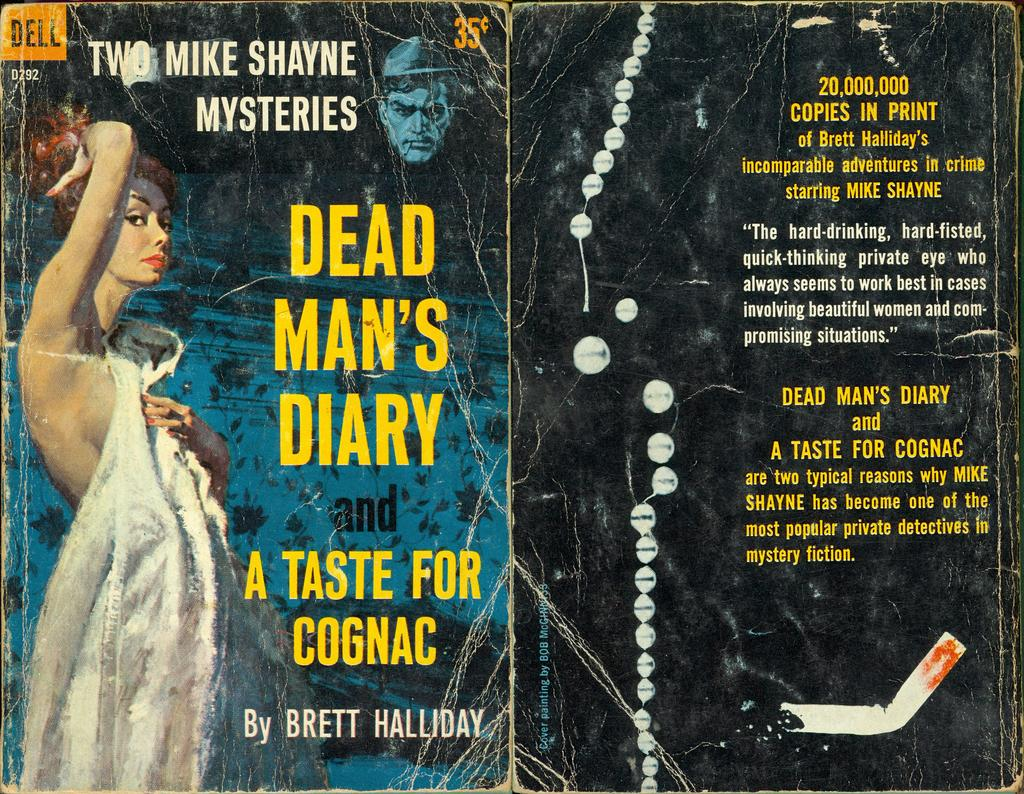Provide a one-sentence caption for the provided image. A book cover by somebody named Brett Halliday. 